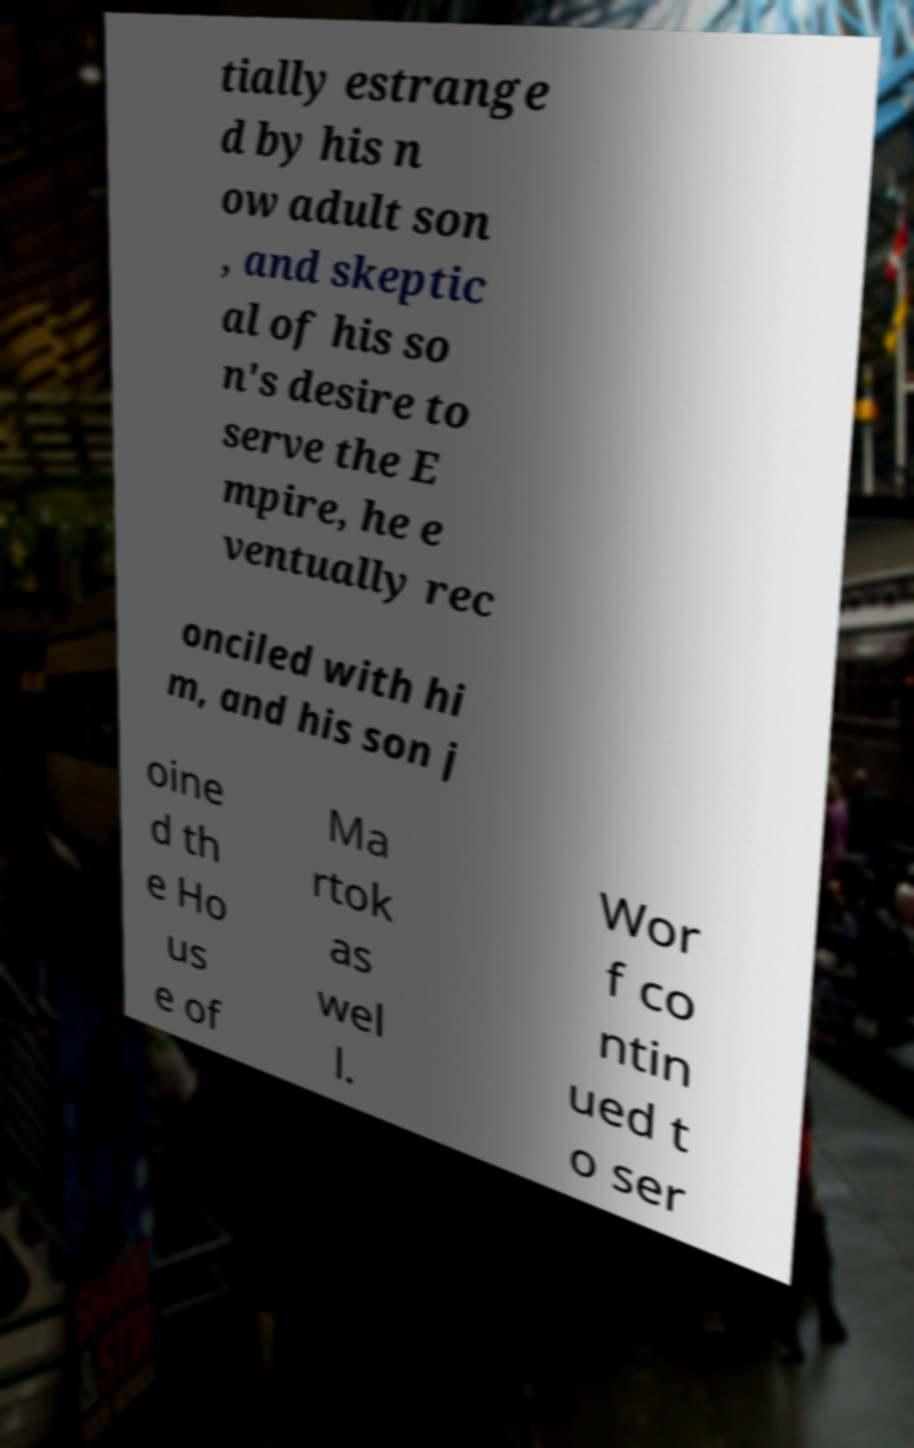I need the written content from this picture converted into text. Can you do that? tially estrange d by his n ow adult son , and skeptic al of his so n's desire to serve the E mpire, he e ventually rec onciled with hi m, and his son j oine d th e Ho us e of Ma rtok as wel l. Wor f co ntin ued t o ser 